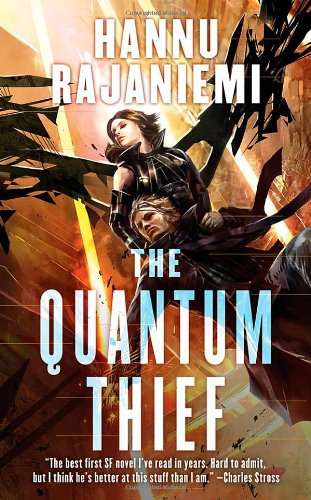What is the genre of this book? This book falls into the 'Science Fiction & Fantasy' genre, offering a rich tapestry of futuristic concepts and imaginative worlds that capture the essence of speculative storytelling. 